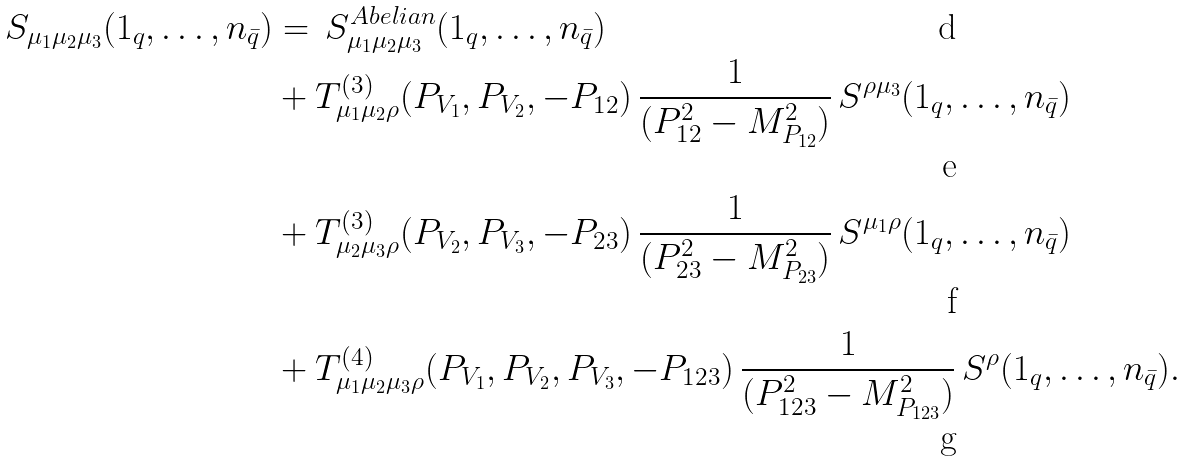<formula> <loc_0><loc_0><loc_500><loc_500>S _ { \mu _ { 1 } \mu _ { 2 } \mu _ { 3 } } ( 1 _ { q } , \dots , n _ { \bar { q } } ) & = \, S _ { \mu _ { 1 } \mu _ { 2 } \mu _ { 3 } } ^ { A b e l i a n } ( 1 _ { q } , \dots , n _ { \bar { q } } ) \\ & + T ^ { ( 3 ) } _ { \mu _ { 1 } \mu _ { 2 } \rho } ( P _ { V _ { 1 } } , P _ { V _ { 2 } } , - P _ { 1 2 } ) \, \frac { 1 } { ( P _ { 1 2 } ^ { 2 } - M _ { P _ { 1 2 } } ^ { 2 } ) } \, S ^ { \rho \mu _ { 3 } } ( 1 _ { q } , \dots , n _ { \bar { q } } ) \\ & + T ^ { ( 3 ) } _ { \mu _ { 2 } \mu _ { 3 } \rho } ( P _ { V _ { 2 } } , P _ { V _ { 3 } } , - P _ { 2 3 } ) \, \frac { 1 } { ( P _ { 2 3 } ^ { 2 } - M _ { P _ { 2 3 } } ^ { 2 } ) } \, S ^ { \mu _ { 1 } \rho } ( 1 _ { q } , \dots , n _ { \bar { q } } ) \\ & + T ^ { ( 4 ) } _ { \mu _ { 1 } \mu _ { 2 } \mu _ { 3 } \rho } ( P _ { V _ { 1 } } , P _ { V _ { 2 } } , P _ { V _ { 3 } } , - P _ { 1 2 3 } ) \, \frac { 1 } { ( P _ { 1 2 3 } ^ { 2 } - M _ { P _ { 1 2 3 } } ^ { 2 } ) } \, S ^ { \rho } ( 1 _ { q } , \dots , n _ { \bar { q } } ) .</formula> 